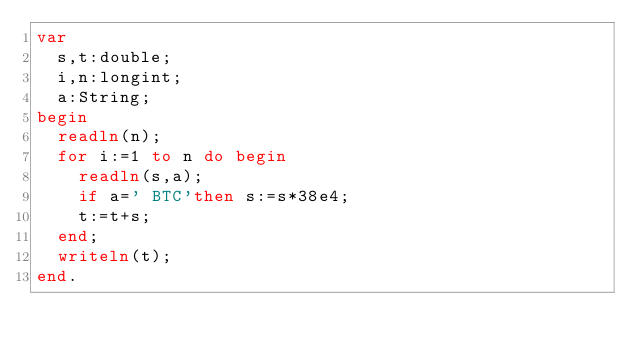<code> <loc_0><loc_0><loc_500><loc_500><_Pascal_>var
	s,t:double;
	i,n:longint;
	a:String;
begin
	readln(n);
	for i:=1 to n do begin
		readln(s,a);
		if a=' BTC'then s:=s*38e4;
		t:=t+s;
	end;
	writeln(t);
end.</code> 